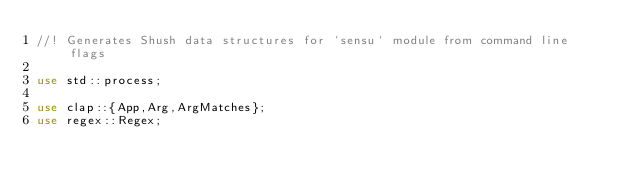Convert code to text. <code><loc_0><loc_0><loc_500><loc_500><_Rust_>//! Generates Shush data structures for `sensu` module from command line flags

use std::process;

use clap::{App,Arg,ArgMatches};
use regex::Regex;
</code> 